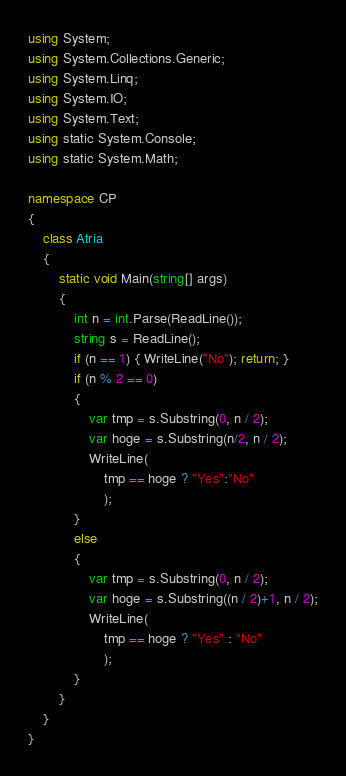<code> <loc_0><loc_0><loc_500><loc_500><_C#_>using System;
using System.Collections.Generic;
using System.Linq;
using System.IO;
using System.Text;
using static System.Console;
using static System.Math;

namespace CP
{
    class Atria
    {
        static void Main(string[] args)
        {
            int n = int.Parse(ReadLine());
            string s = ReadLine();
            if (n == 1) { WriteLine("No"); return; }
            if (n % 2 == 0)
            {
                var tmp = s.Substring(0, n / 2);
                var hoge = s.Substring(n/2, n / 2);
                WriteLine(
                    tmp == hoge ? "Yes":"No"
                    );
            }
            else
            {
                var tmp = s.Substring(0, n / 2);
                var hoge = s.Substring((n / 2)+1, n / 2);
                WriteLine(
                    tmp == hoge ? "Yes" : "No"
                    );
            }
        }
    }
}
</code> 